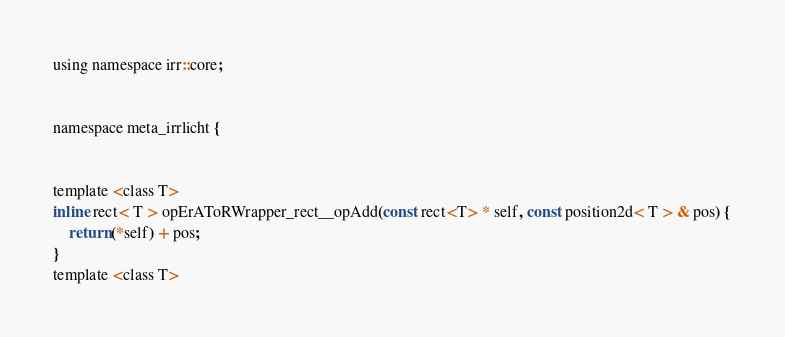<code> <loc_0><loc_0><loc_500><loc_500><_C_>using namespace irr::core;


namespace meta_irrlicht { 


template <class T>
inline rect< T > opErAToRWrapper_rect__opAdd(const rect<T> * self, const position2d< T > & pos) {
    return (*self) + pos;
}
template <class T></code> 